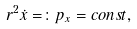<formula> <loc_0><loc_0><loc_500><loc_500>r ^ { 2 } \dot { x } = \colon p _ { x } = c o n s t ,</formula> 